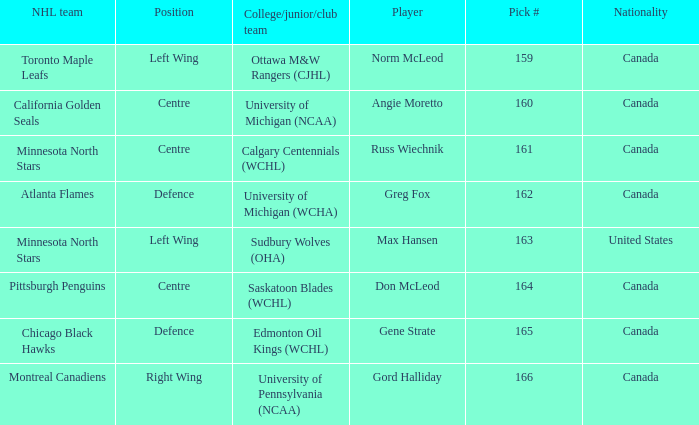Could you parse the entire table? {'header': ['NHL team', 'Position', 'College/junior/club team', 'Player', 'Pick #', 'Nationality'], 'rows': [['Toronto Maple Leafs', 'Left Wing', 'Ottawa M&W Rangers (CJHL)', 'Norm McLeod', '159', 'Canada'], ['California Golden Seals', 'Centre', 'University of Michigan (NCAA)', 'Angie Moretto', '160', 'Canada'], ['Minnesota North Stars', 'Centre', 'Calgary Centennials (WCHL)', 'Russ Wiechnik', '161', 'Canada'], ['Atlanta Flames', 'Defence', 'University of Michigan (WCHA)', 'Greg Fox', '162', 'Canada'], ['Minnesota North Stars', 'Left Wing', 'Sudbury Wolves (OHA)', 'Max Hansen', '163', 'United States'], ['Pittsburgh Penguins', 'Centre', 'Saskatoon Blades (WCHL)', 'Don McLeod', '164', 'Canada'], ['Chicago Black Hawks', 'Defence', 'Edmonton Oil Kings (WCHL)', 'Gene Strate', '165', 'Canada'], ['Montreal Canadiens', 'Right Wing', 'University of Pennsylvania (NCAA)', 'Gord Halliday', '166', 'Canada']]} What NHL team was the player from Calgary Centennials (WCHL) drafted for? Minnesota North Stars. 